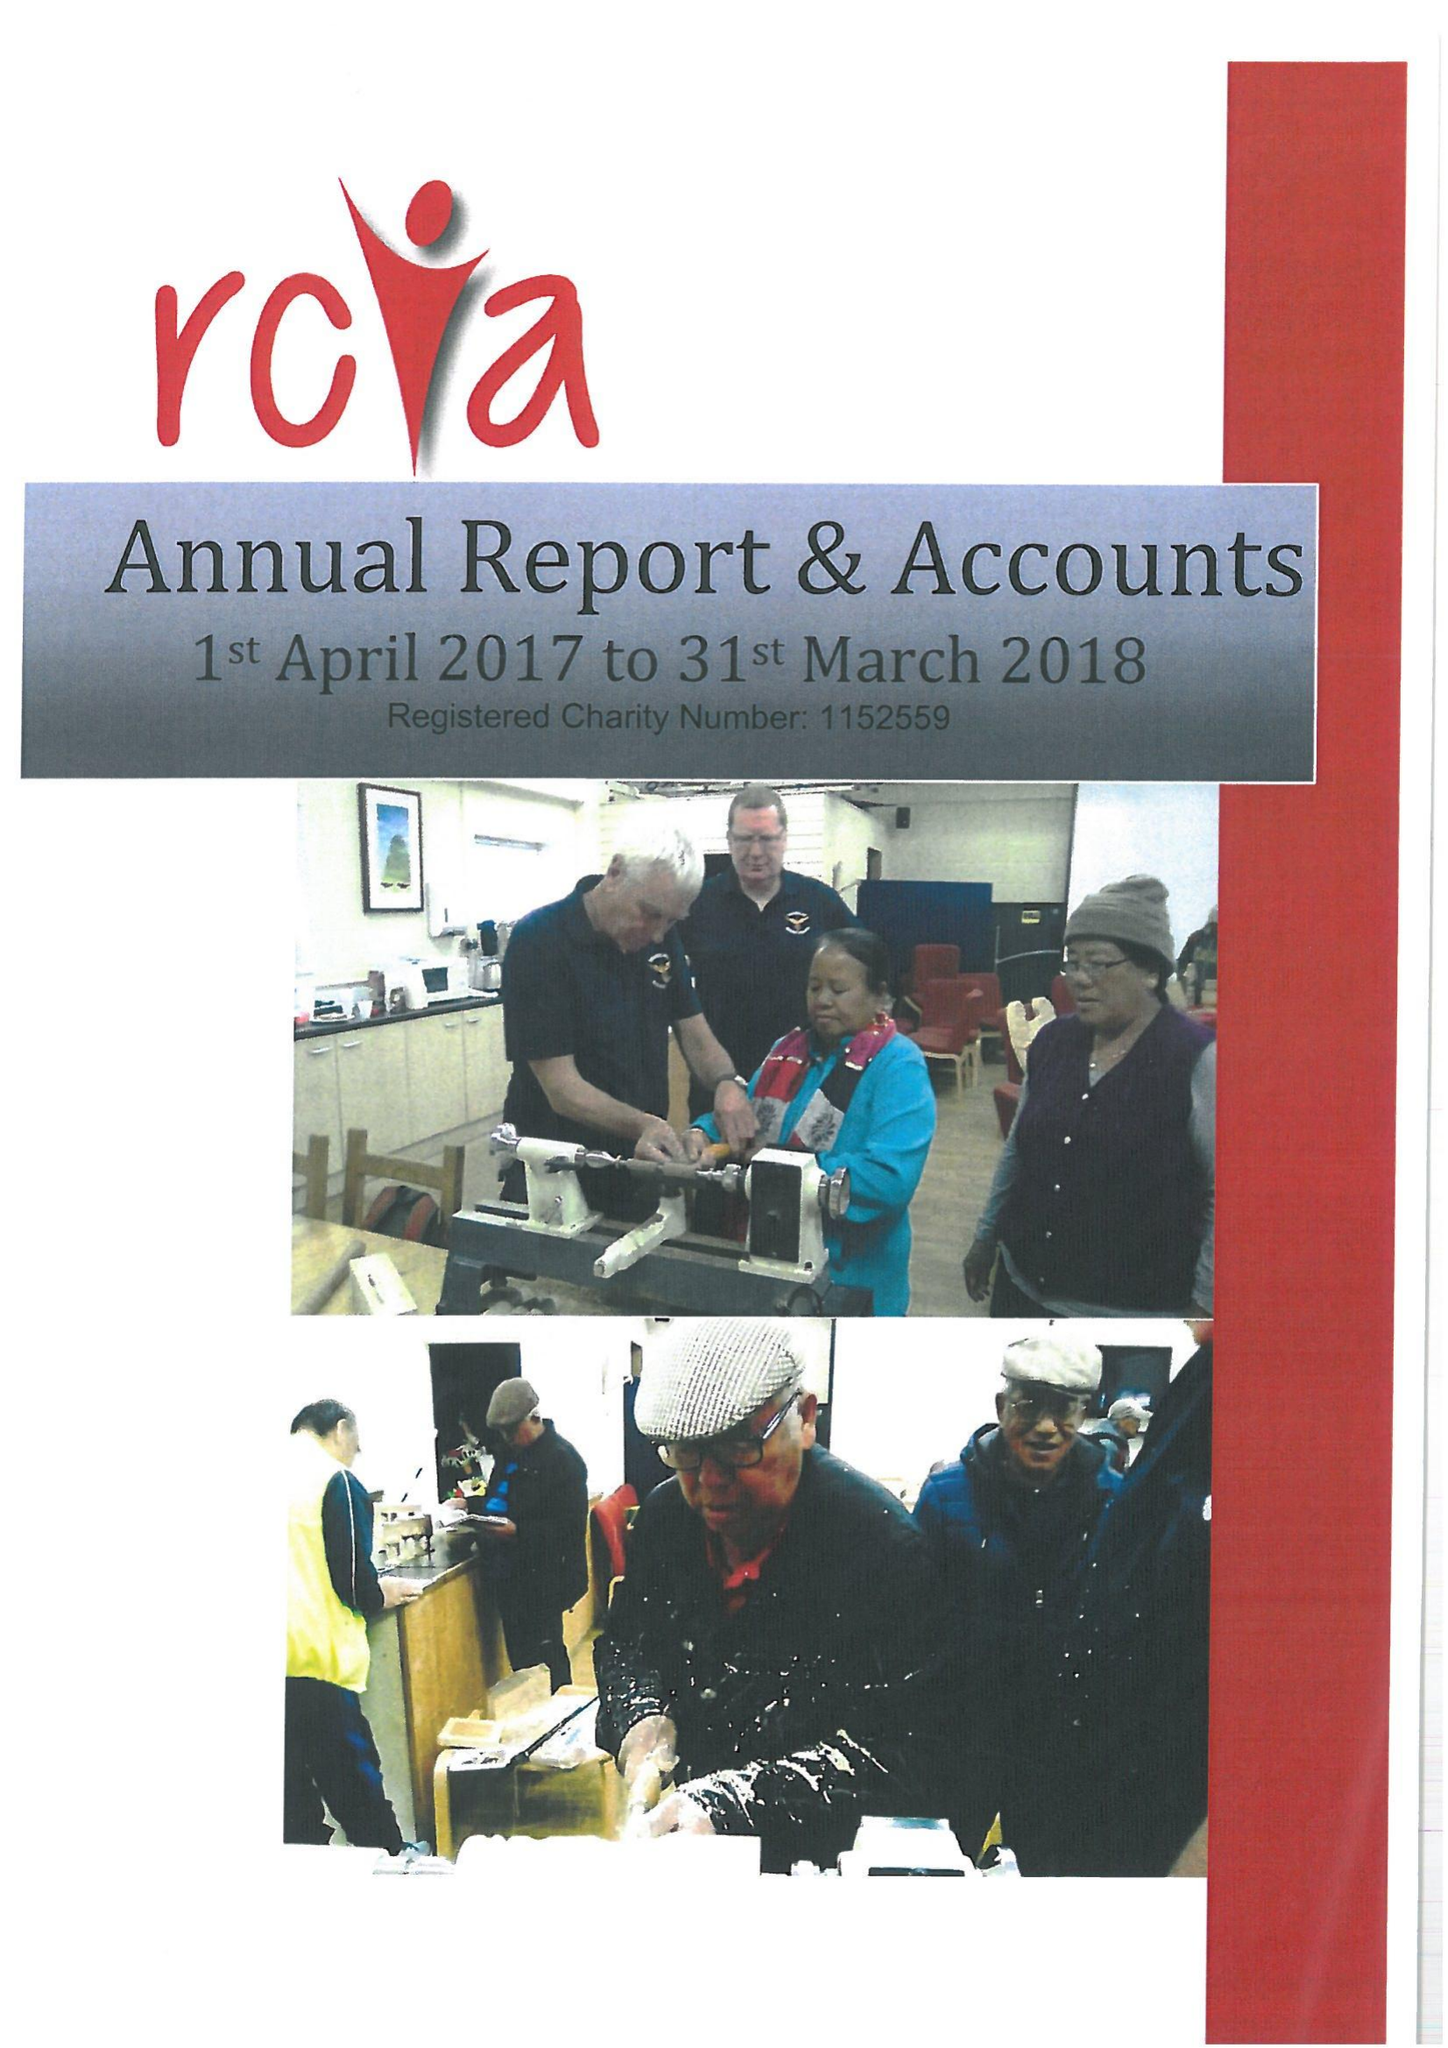What is the value for the charity_name?
Answer the question using a single word or phrase. Richmondshire Community and Voluntary Action 